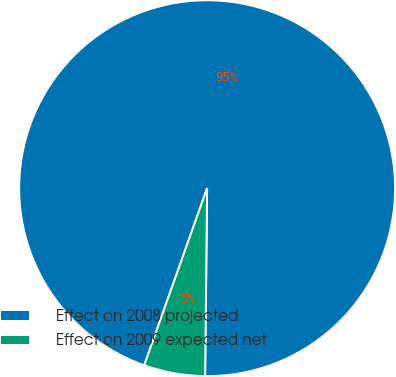Convert chart. <chart><loc_0><loc_0><loc_500><loc_500><pie_chart><fcel>Effect on 2008 projected<fcel>Effect on 2009 expected net<nl><fcel>94.74%<fcel>5.26%<nl></chart> 